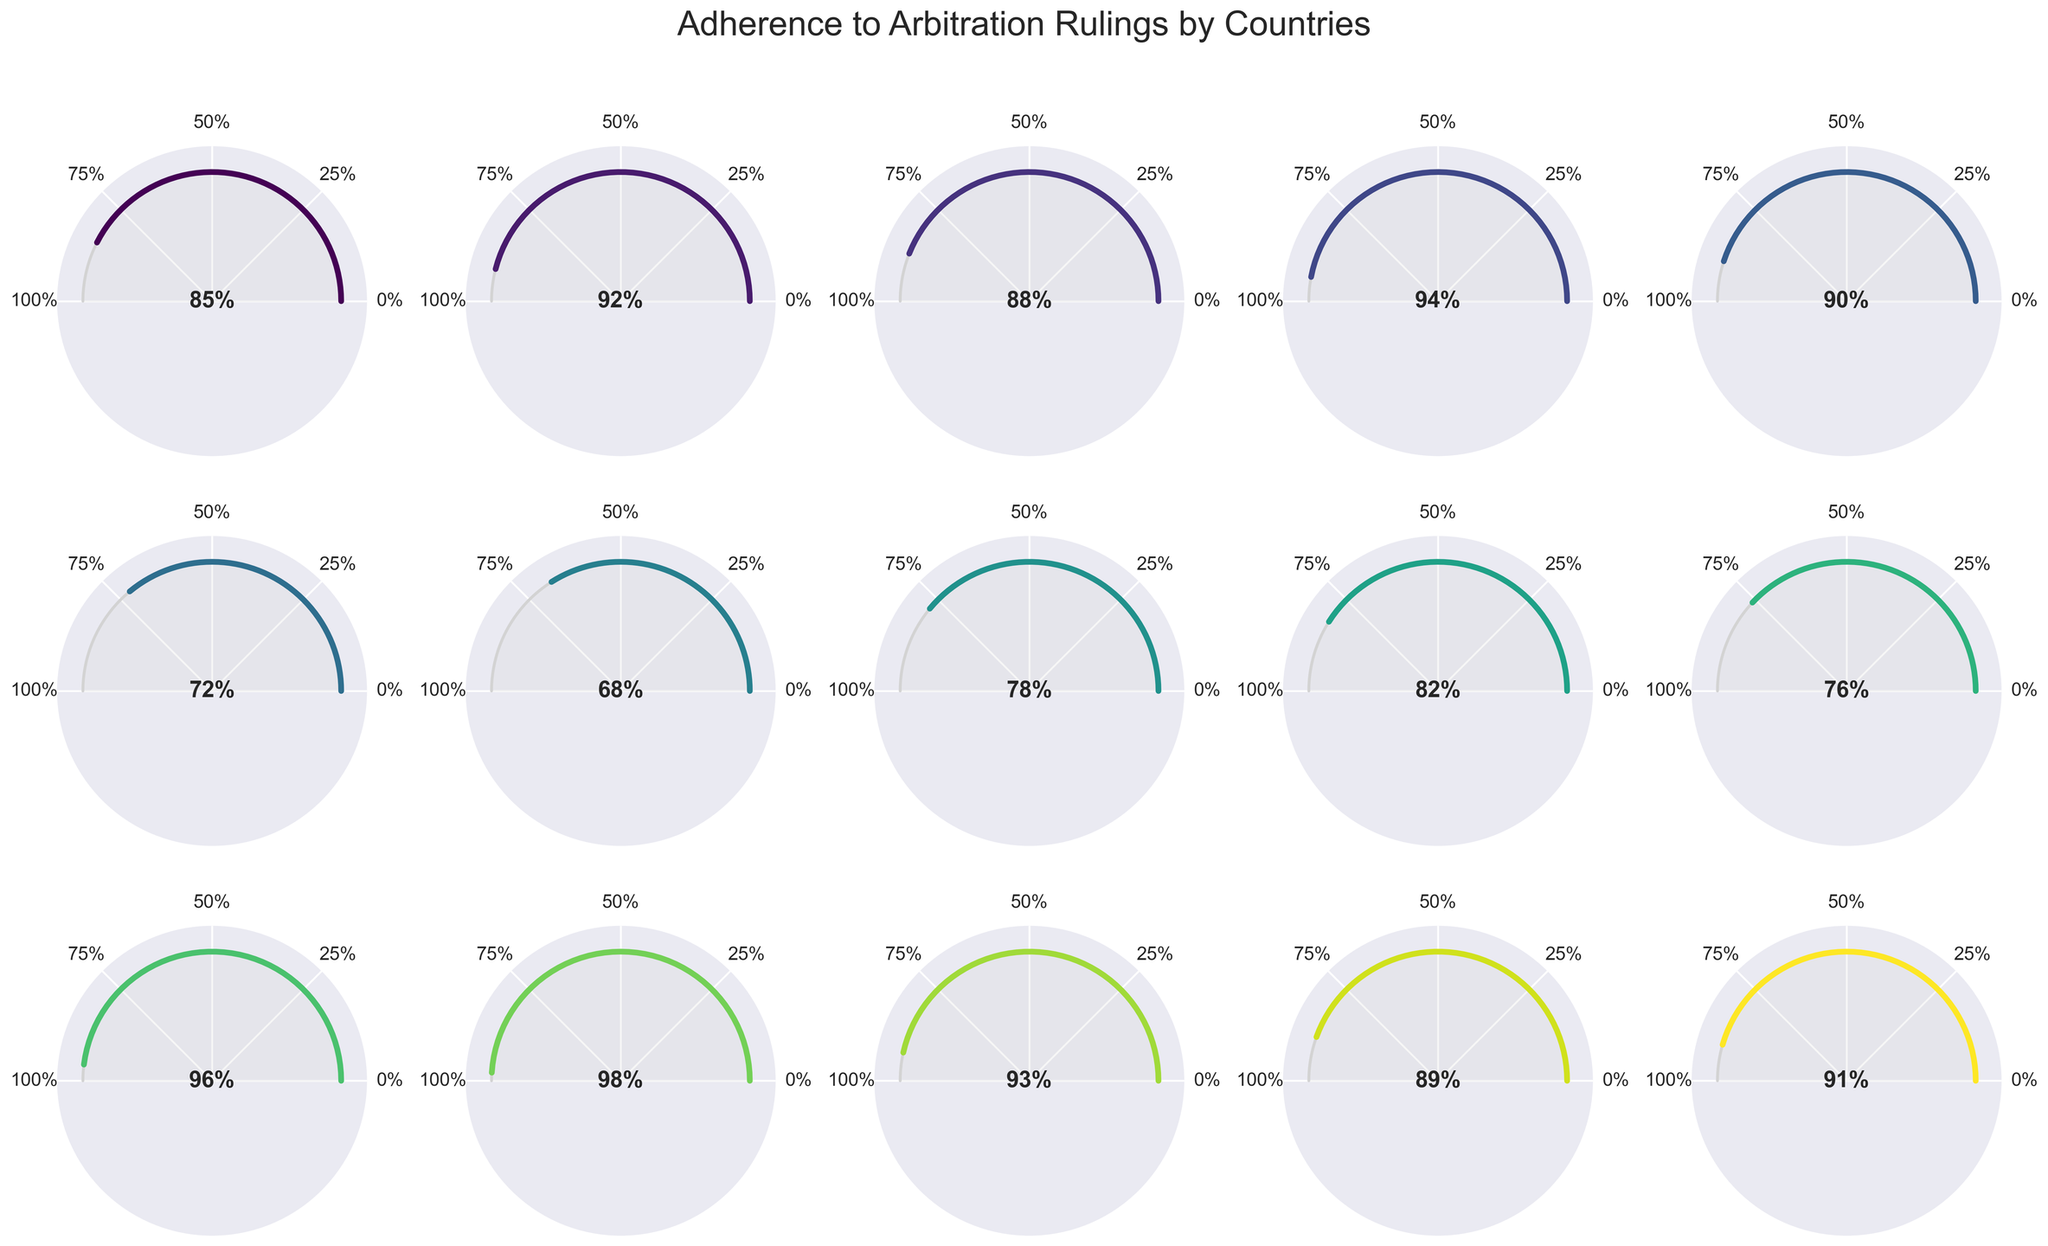Which country has the highest adherence percentage? Sweden has the highest adherence percentage at 96% based on the values provided.
Answer: Sweden How many countries have an adherence percentage of 90% or higher? The countries with adherence percentages of 90% or higher are the United Kingdom (92%), Germany (94%), Japan (90%), Sweden (96%), Switzerland (98%), the Netherlands (93%), and Australia (91%). There are 7 such countries.
Answer: 7 Which country has the lowest adherence percentage? China has the lowest adherence percentage at 68%.
Answer: China What is the median adherence percentage among the countries? The adherence percentages in ascending order are: 68, 72, 76, 78, 82, 85, 88, 89, 90, 91, 92, 93, 94, 96, 98. The middle value (8th value) is 89.
Answer: 89 Which country has an adherence percentage closest to 85%? The United States has an adherence percentage of 85%.
Answer: United States What are the adherence percentages of countries from North America? The countries from North America are the United States and Canada with adherence percentages of 85% and 89%, respectively.
Answer: 85% and 89% By how much does Germany's adherence percentage exceed Argentina's? Germany's adherence percentage is 94%, and Argentina's is 76%. The difference is 94% - 76% = 18%.
Answer: 18% What is the average adherence percentage of countries in Europe listed on the plot? Europe includes the United Kingdom (92%), France (88%), Germany (94%), Sweden (96%), Switzerland (98%), Netherlands (93%). The sum is 92+88+94+96+98+93=561, and with six countries, the average is 561/6 = 93.5%.
Answer: 93.5% How does Brazil's adherence percentage compare with India's? Brazil has an adherence percentage of 82%, while India has 78%. Brazil's percentage is 4% higher than India's.
Answer: 4% higher How is the adherence percentage represented in the gauge chart for each country? Each gauge chart shows a semi-circular plot where the angle covered by the colored arc represents the percentage adherence, with specific labels for 0%, 25%, 50%, 75%, and 100% adherence. The colored arc's extent visually indicates adherence.
Answer: By the angle of the colored arc 